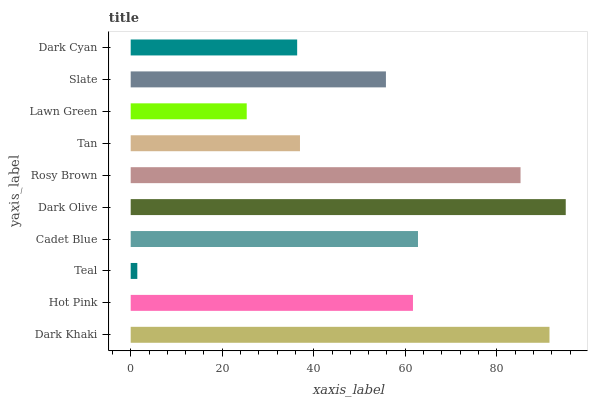Is Teal the minimum?
Answer yes or no. Yes. Is Dark Olive the maximum?
Answer yes or no. Yes. Is Hot Pink the minimum?
Answer yes or no. No. Is Hot Pink the maximum?
Answer yes or no. No. Is Dark Khaki greater than Hot Pink?
Answer yes or no. Yes. Is Hot Pink less than Dark Khaki?
Answer yes or no. Yes. Is Hot Pink greater than Dark Khaki?
Answer yes or no. No. Is Dark Khaki less than Hot Pink?
Answer yes or no. No. Is Hot Pink the high median?
Answer yes or no. Yes. Is Slate the low median?
Answer yes or no. Yes. Is Dark Olive the high median?
Answer yes or no. No. Is Dark Olive the low median?
Answer yes or no. No. 